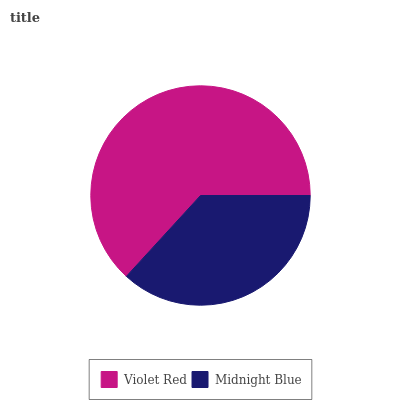Is Midnight Blue the minimum?
Answer yes or no. Yes. Is Violet Red the maximum?
Answer yes or no. Yes. Is Midnight Blue the maximum?
Answer yes or no. No. Is Violet Red greater than Midnight Blue?
Answer yes or no. Yes. Is Midnight Blue less than Violet Red?
Answer yes or no. Yes. Is Midnight Blue greater than Violet Red?
Answer yes or no. No. Is Violet Red less than Midnight Blue?
Answer yes or no. No. Is Violet Red the high median?
Answer yes or no. Yes. Is Midnight Blue the low median?
Answer yes or no. Yes. Is Midnight Blue the high median?
Answer yes or no. No. Is Violet Red the low median?
Answer yes or no. No. 